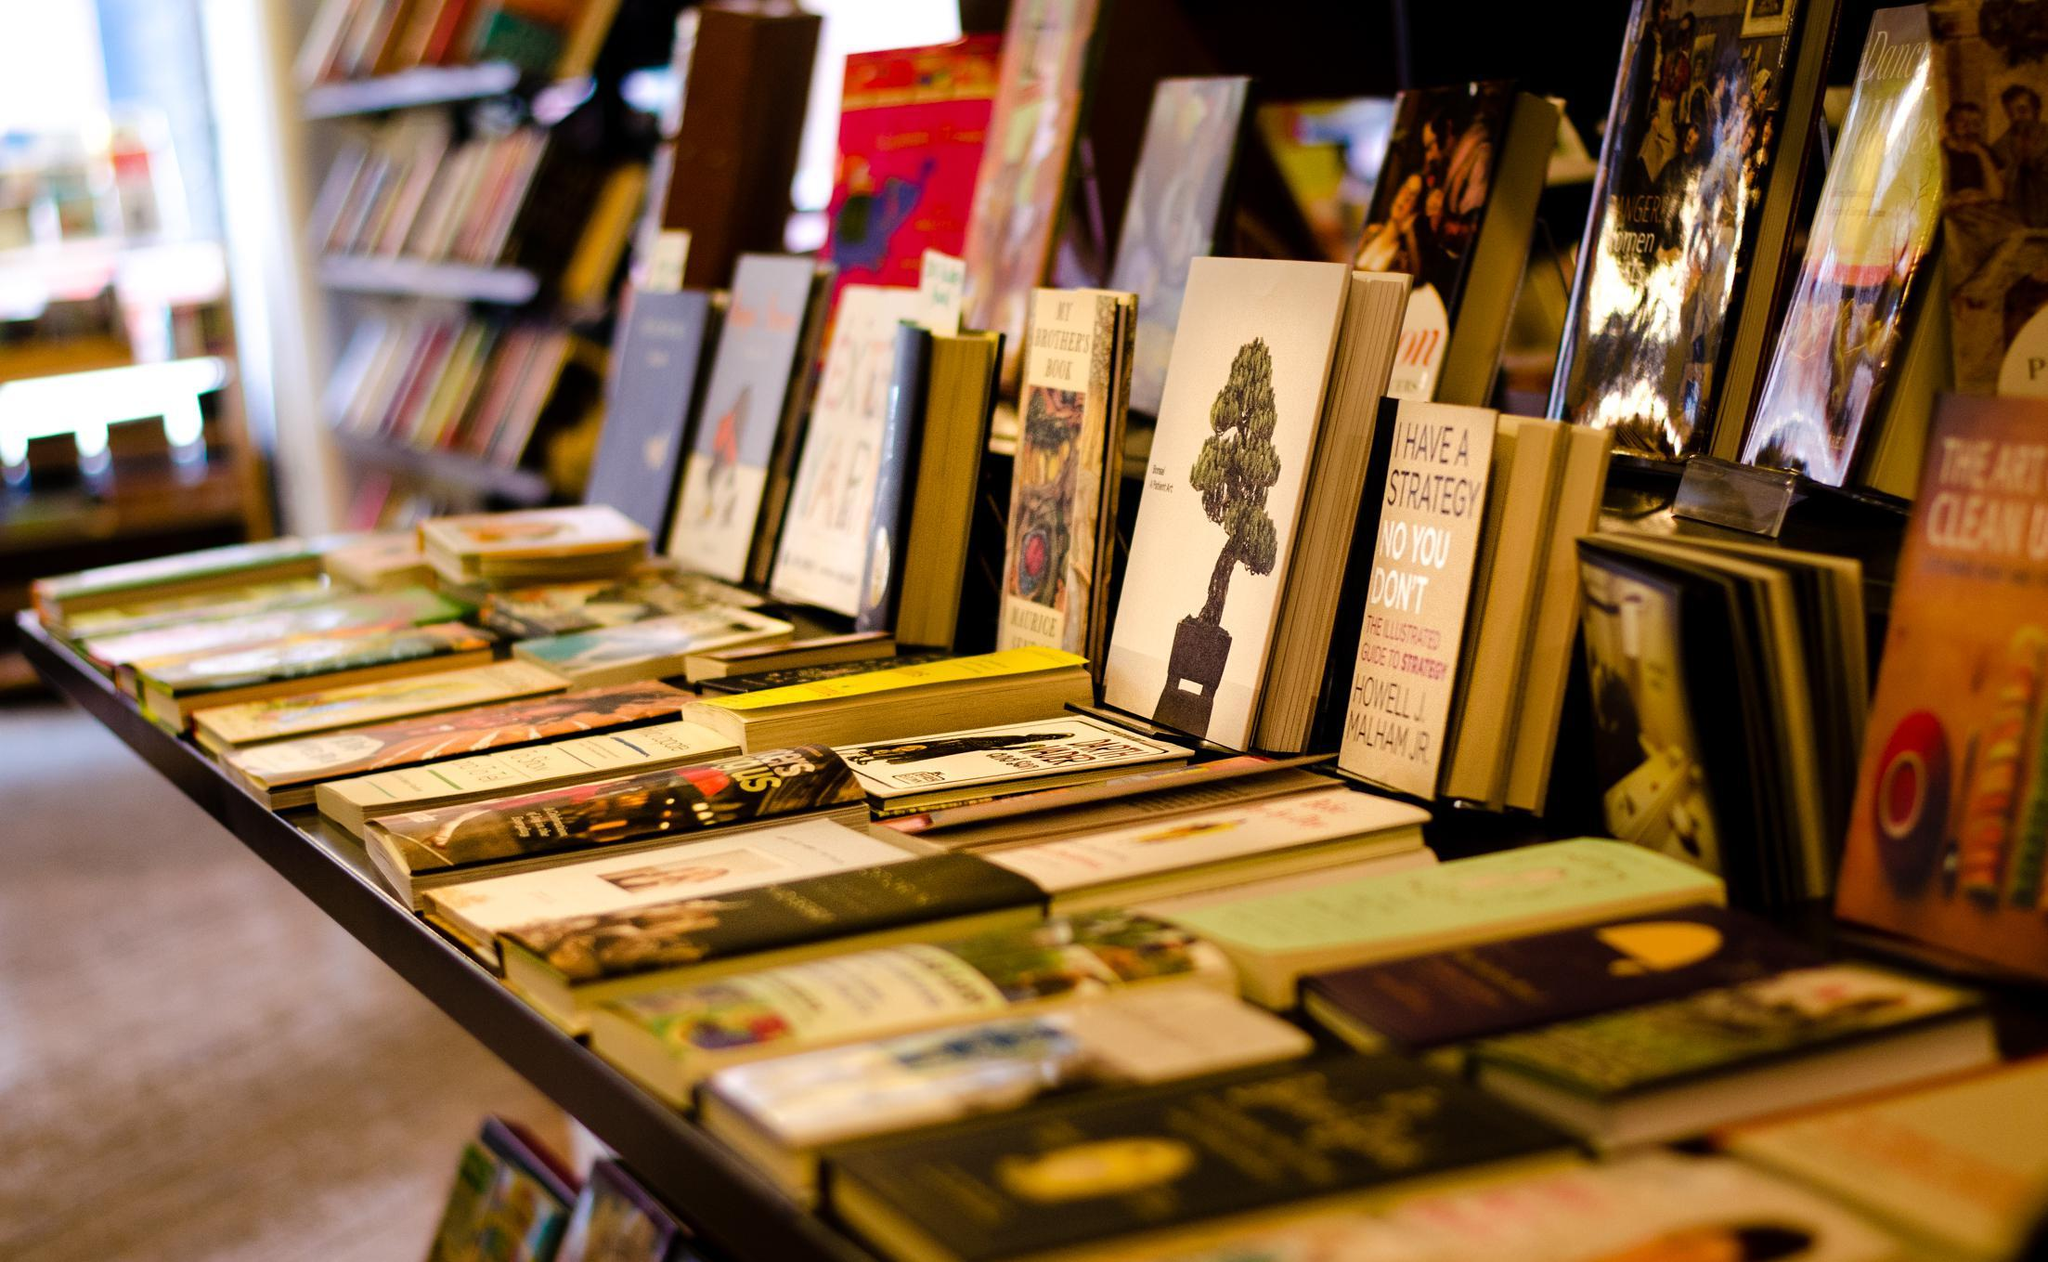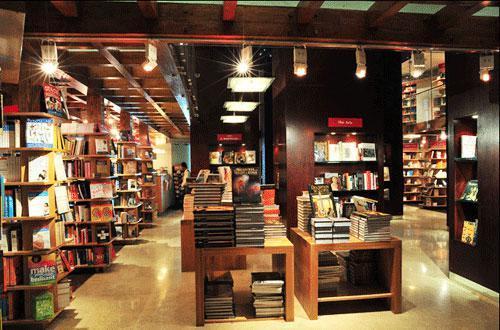The first image is the image on the left, the second image is the image on the right. Evaluate the accuracy of this statement regarding the images: "In one image, wooden tables in the foreground of a bookstore are stacked with books for sale, with more books visible on the floor under or near the tables.". Is it true? Answer yes or no. Yes. The first image is the image on the left, the second image is the image on the right. Analyze the images presented: Is the assertion "One bookstore interior shows central table displays flanked by empty aisles, and the other interior shows a table display with upright and flat books." valid? Answer yes or no. Yes. 